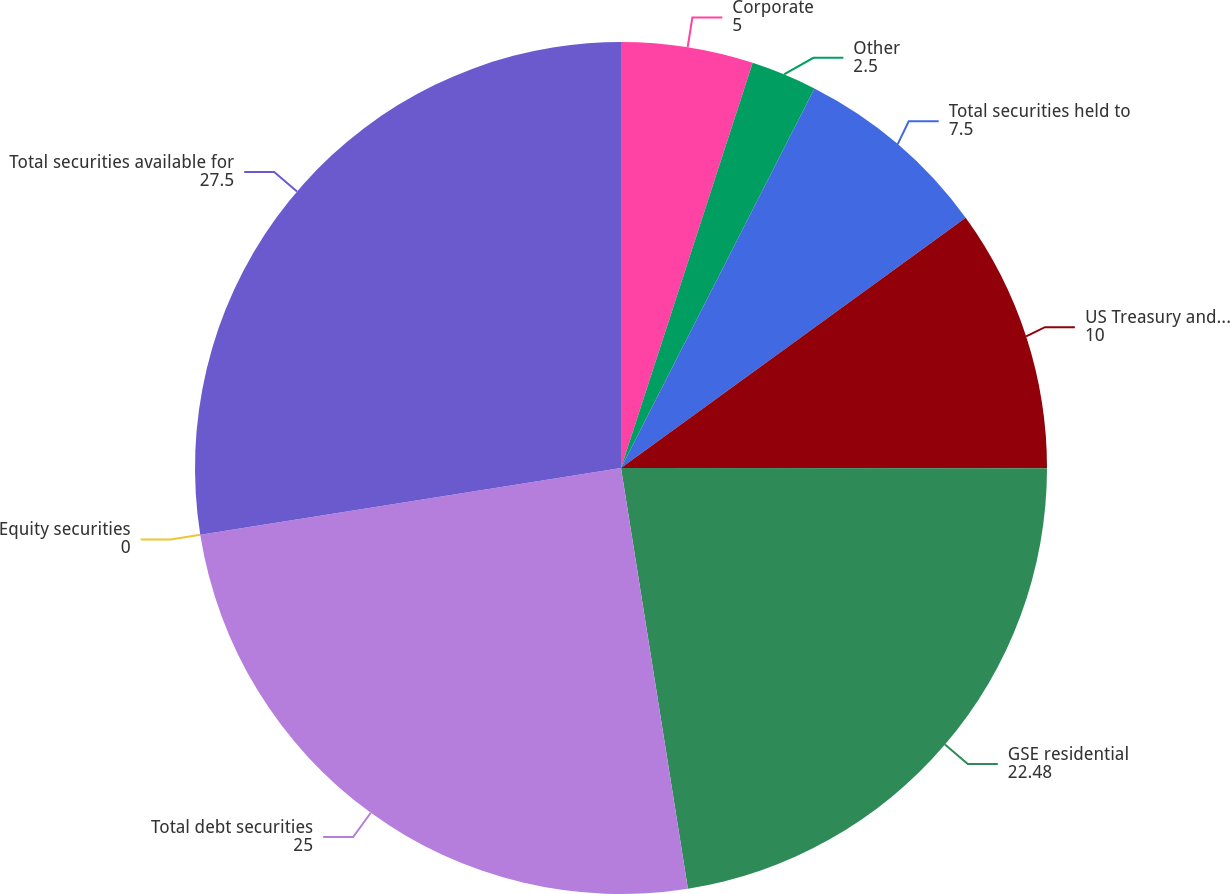Convert chart. <chart><loc_0><loc_0><loc_500><loc_500><pie_chart><fcel>Corporate<fcel>Other<fcel>Total securities held to<fcel>US Treasury and agency<fcel>GSE residential<fcel>Total debt securities<fcel>Equity securities<fcel>Total securities available for<nl><fcel>5.0%<fcel>2.5%<fcel>7.5%<fcel>10.0%<fcel>22.48%<fcel>25.0%<fcel>0.0%<fcel>27.5%<nl></chart> 